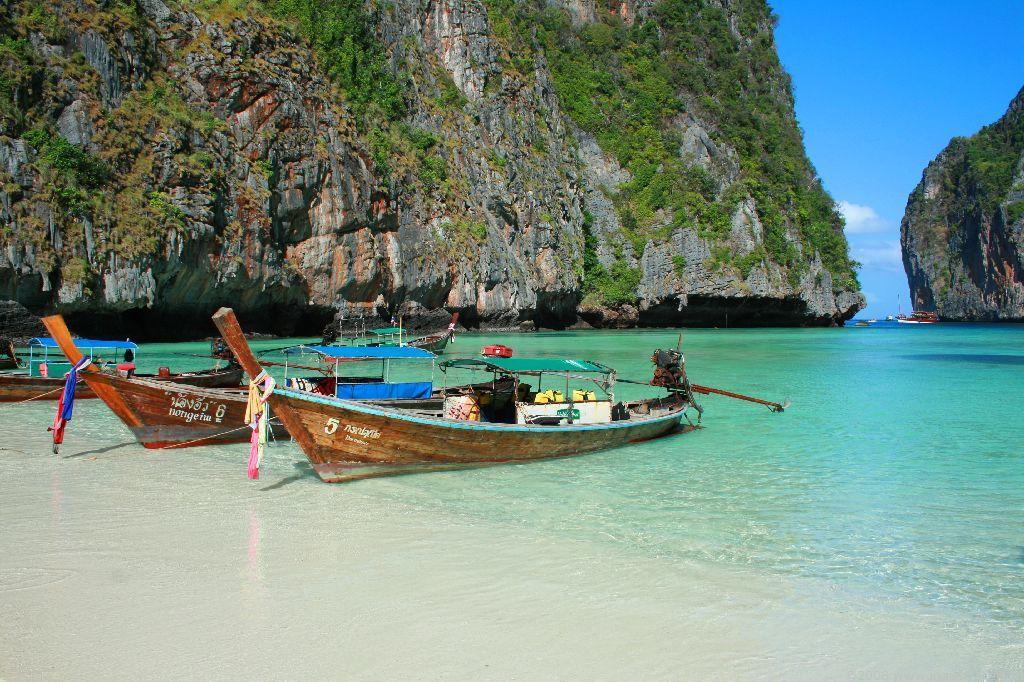What number is on the boat with the green roof?
Your response must be concise. 5. 